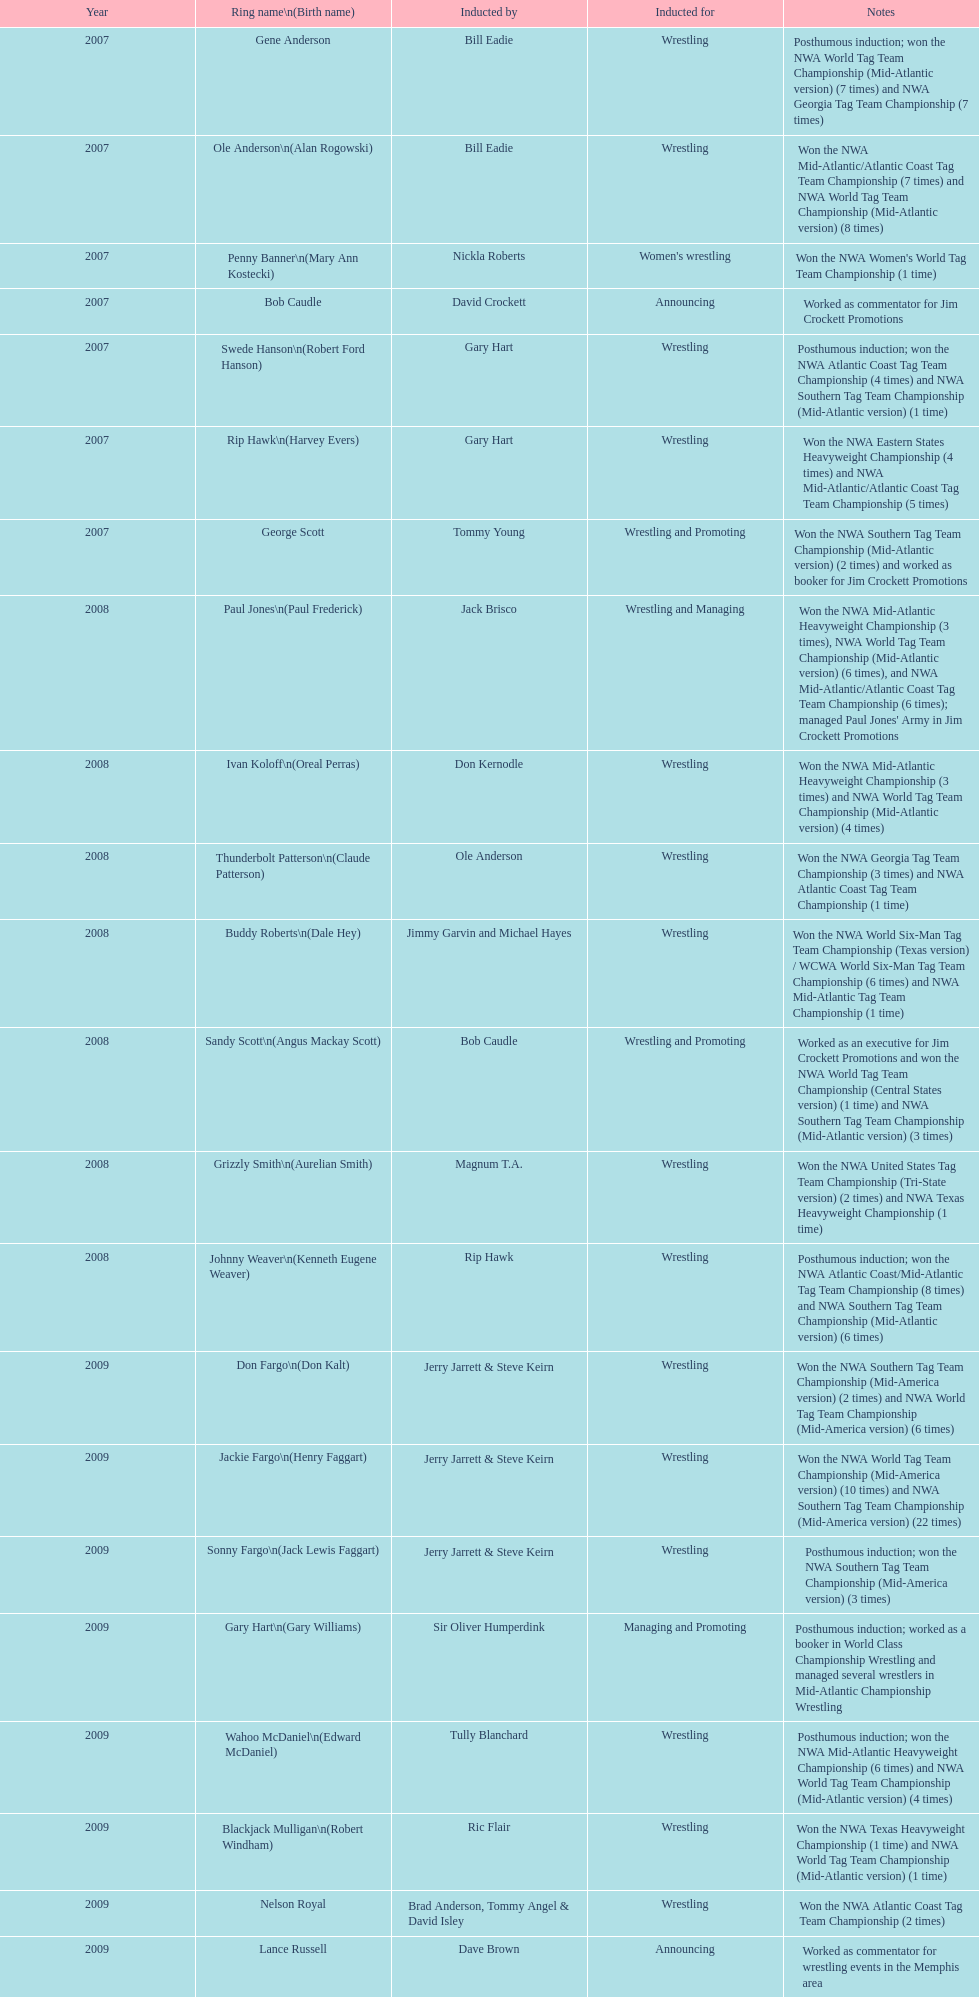Find the word(s) posthumous in the notes column. Posthumous induction; won the NWA World Tag Team Championship (Mid-Atlantic version) (7 times) and NWA Georgia Tag Team Championship (7 times), Posthumous induction; won the NWA Atlantic Coast Tag Team Championship (4 times) and NWA Southern Tag Team Championship (Mid-Atlantic version) (1 time), Posthumous induction; won the NWA Atlantic Coast/Mid-Atlantic Tag Team Championship (8 times) and NWA Southern Tag Team Championship (Mid-Atlantic version) (6 times), Posthumous induction; won the NWA Southern Tag Team Championship (Mid-America version) (3 times), Posthumous induction; worked as a booker in World Class Championship Wrestling and managed several wrestlers in Mid-Atlantic Championship Wrestling, Posthumous induction; won the NWA Mid-Atlantic Heavyweight Championship (6 times) and NWA World Tag Team Championship (Mid-Atlantic version) (4 times). What is the earliest year in the table that wrestlers were inducted? 2007, 2007, 2007, 2007, 2007, 2007, 2007. Find the wrestlers that wrestled underneath their birth name in the earliest year of induction. Gene Anderson, Bob Caudle, George Scott. Of the wrestlers who wrestled underneath their birth name in the earliest year of induction was one of them inducted posthumously? Gene Anderson. 